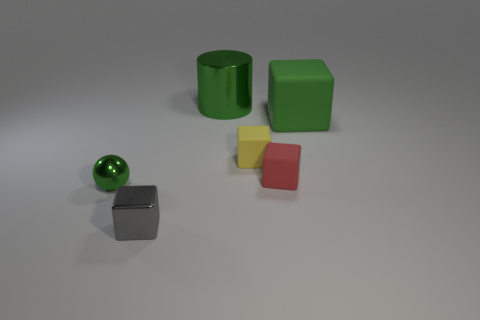What number of rubber things are either brown blocks or green spheres?
Provide a short and direct response. 0. Is the number of shiny cylinders that are left of the cylinder less than the number of large cubes?
Provide a short and direct response. Yes. What shape is the green object that is in front of the thing that is on the right side of the small matte object in front of the yellow cube?
Ensure brevity in your answer.  Sphere. Do the large matte block and the cylinder have the same color?
Give a very brief answer. Yes. Are there more shiny cylinders than big yellow shiny objects?
Keep it short and to the point. Yes. What number of other objects are the same material as the large block?
Keep it short and to the point. 2. How many things are small gray rubber objects or small metal balls on the left side of the yellow rubber cube?
Keep it short and to the point. 1. Is the number of green rubber blocks less than the number of big green metallic spheres?
Keep it short and to the point. No. What color is the block on the left side of the green metal object on the right side of the green shiny thing in front of the big green rubber thing?
Your answer should be very brief. Gray. Do the tiny green sphere and the cylinder have the same material?
Your response must be concise. Yes. 